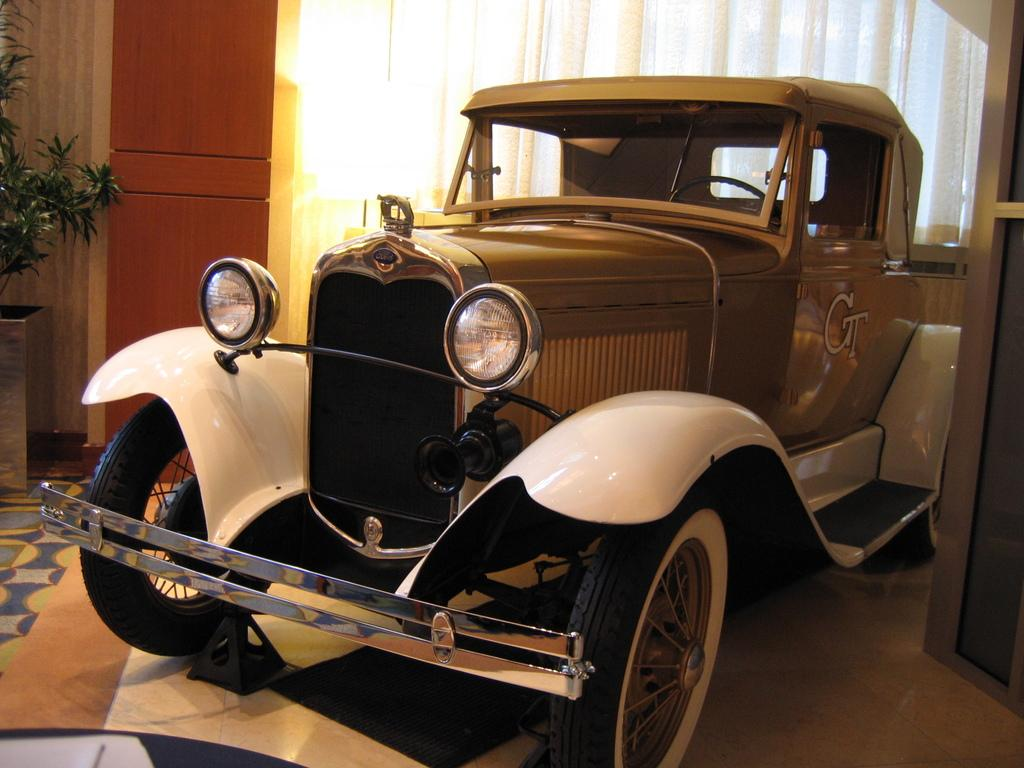What type of vehicle is present in the room? There is a vintage car in the room. What type of window treatment is visible in the image? There is a white curtain visible in the image. What material is used for the wall in the background? There is a wooden panel wall in the background. What type of music can be heard coming from the vintage car in the image? There is no indication in the image that the vintage car is playing music, so it cannot be determined from the picture. 